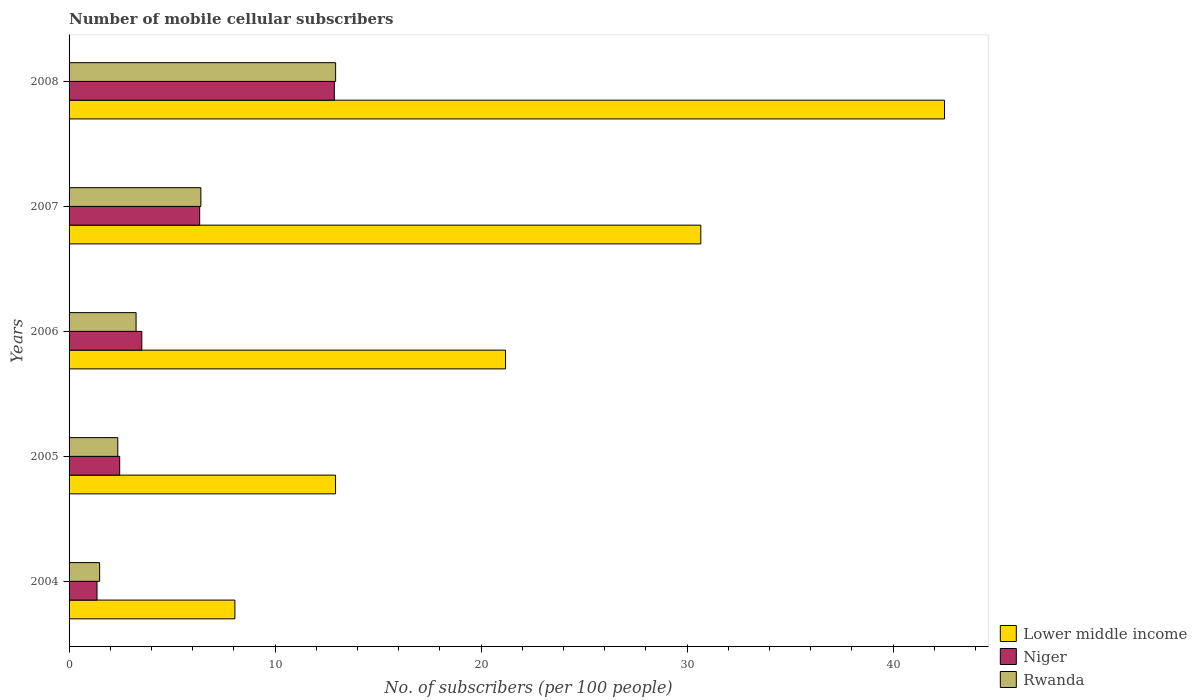How many groups of bars are there?
Offer a very short reply. 5. Are the number of bars on each tick of the Y-axis equal?
Your answer should be very brief. Yes. How many bars are there on the 3rd tick from the top?
Provide a short and direct response. 3. In how many cases, is the number of bars for a given year not equal to the number of legend labels?
Your answer should be compact. 0. What is the number of mobile cellular subscribers in Lower middle income in 2005?
Ensure brevity in your answer.  12.93. Across all years, what is the maximum number of mobile cellular subscribers in Rwanda?
Your response must be concise. 12.94. Across all years, what is the minimum number of mobile cellular subscribers in Rwanda?
Keep it short and to the point. 1.48. In which year was the number of mobile cellular subscribers in Rwanda maximum?
Your answer should be compact. 2008. In which year was the number of mobile cellular subscribers in Lower middle income minimum?
Provide a succinct answer. 2004. What is the total number of mobile cellular subscribers in Niger in the graph?
Keep it short and to the point. 26.56. What is the difference between the number of mobile cellular subscribers in Rwanda in 2005 and that in 2008?
Offer a very short reply. -10.57. What is the difference between the number of mobile cellular subscribers in Niger in 2004 and the number of mobile cellular subscribers in Rwanda in 2005?
Your response must be concise. -1.01. What is the average number of mobile cellular subscribers in Niger per year?
Provide a short and direct response. 5.31. In the year 2005, what is the difference between the number of mobile cellular subscribers in Rwanda and number of mobile cellular subscribers in Niger?
Make the answer very short. -0.09. What is the ratio of the number of mobile cellular subscribers in Lower middle income in 2004 to that in 2008?
Your answer should be compact. 0.19. Is the difference between the number of mobile cellular subscribers in Rwanda in 2005 and 2007 greater than the difference between the number of mobile cellular subscribers in Niger in 2005 and 2007?
Your answer should be compact. No. What is the difference between the highest and the second highest number of mobile cellular subscribers in Rwanda?
Offer a very short reply. 6.54. What is the difference between the highest and the lowest number of mobile cellular subscribers in Lower middle income?
Your answer should be very brief. 34.44. In how many years, is the number of mobile cellular subscribers in Rwanda greater than the average number of mobile cellular subscribers in Rwanda taken over all years?
Ensure brevity in your answer.  2. What does the 3rd bar from the top in 2008 represents?
Provide a short and direct response. Lower middle income. What does the 2nd bar from the bottom in 2008 represents?
Your answer should be compact. Niger. What is the difference between two consecutive major ticks on the X-axis?
Keep it short and to the point. 10. Are the values on the major ticks of X-axis written in scientific E-notation?
Your response must be concise. No. Does the graph contain any zero values?
Offer a terse response. No. Where does the legend appear in the graph?
Give a very brief answer. Bottom right. How many legend labels are there?
Give a very brief answer. 3. What is the title of the graph?
Make the answer very short. Number of mobile cellular subscribers. Does "Australia" appear as one of the legend labels in the graph?
Give a very brief answer. No. What is the label or title of the X-axis?
Ensure brevity in your answer.  No. of subscribers (per 100 people). What is the label or title of the Y-axis?
Give a very brief answer. Years. What is the No. of subscribers (per 100 people) in Lower middle income in 2004?
Provide a succinct answer. 8.05. What is the No. of subscribers (per 100 people) in Niger in 2004?
Ensure brevity in your answer.  1.36. What is the No. of subscribers (per 100 people) of Rwanda in 2004?
Make the answer very short. 1.48. What is the No. of subscribers (per 100 people) in Lower middle income in 2005?
Make the answer very short. 12.93. What is the No. of subscribers (per 100 people) of Niger in 2005?
Ensure brevity in your answer.  2.46. What is the No. of subscribers (per 100 people) in Rwanda in 2005?
Provide a succinct answer. 2.36. What is the No. of subscribers (per 100 people) of Lower middle income in 2006?
Provide a short and direct response. 21.19. What is the No. of subscribers (per 100 people) in Niger in 2006?
Offer a very short reply. 3.53. What is the No. of subscribers (per 100 people) in Rwanda in 2006?
Make the answer very short. 3.25. What is the No. of subscribers (per 100 people) in Lower middle income in 2007?
Offer a terse response. 30.66. What is the No. of subscribers (per 100 people) of Niger in 2007?
Offer a very short reply. 6.34. What is the No. of subscribers (per 100 people) of Rwanda in 2007?
Offer a terse response. 6.4. What is the No. of subscribers (per 100 people) in Lower middle income in 2008?
Give a very brief answer. 42.49. What is the No. of subscribers (per 100 people) of Niger in 2008?
Keep it short and to the point. 12.88. What is the No. of subscribers (per 100 people) of Rwanda in 2008?
Offer a very short reply. 12.94. Across all years, what is the maximum No. of subscribers (per 100 people) of Lower middle income?
Keep it short and to the point. 42.49. Across all years, what is the maximum No. of subscribers (per 100 people) in Niger?
Your response must be concise. 12.88. Across all years, what is the maximum No. of subscribers (per 100 people) of Rwanda?
Your response must be concise. 12.94. Across all years, what is the minimum No. of subscribers (per 100 people) in Lower middle income?
Your answer should be compact. 8.05. Across all years, what is the minimum No. of subscribers (per 100 people) of Niger?
Your answer should be very brief. 1.36. Across all years, what is the minimum No. of subscribers (per 100 people) in Rwanda?
Your answer should be compact. 1.48. What is the total No. of subscribers (per 100 people) of Lower middle income in the graph?
Provide a short and direct response. 115.32. What is the total No. of subscribers (per 100 people) of Niger in the graph?
Ensure brevity in your answer.  26.56. What is the total No. of subscribers (per 100 people) of Rwanda in the graph?
Offer a terse response. 26.44. What is the difference between the No. of subscribers (per 100 people) of Lower middle income in 2004 and that in 2005?
Provide a succinct answer. -4.89. What is the difference between the No. of subscribers (per 100 people) of Niger in 2004 and that in 2005?
Provide a short and direct response. -1.1. What is the difference between the No. of subscribers (per 100 people) in Rwanda in 2004 and that in 2005?
Provide a succinct answer. -0.88. What is the difference between the No. of subscribers (per 100 people) of Lower middle income in 2004 and that in 2006?
Give a very brief answer. -13.14. What is the difference between the No. of subscribers (per 100 people) of Niger in 2004 and that in 2006?
Offer a terse response. -2.17. What is the difference between the No. of subscribers (per 100 people) of Rwanda in 2004 and that in 2006?
Your answer should be very brief. -1.77. What is the difference between the No. of subscribers (per 100 people) in Lower middle income in 2004 and that in 2007?
Offer a very short reply. -22.61. What is the difference between the No. of subscribers (per 100 people) of Niger in 2004 and that in 2007?
Your answer should be compact. -4.98. What is the difference between the No. of subscribers (per 100 people) in Rwanda in 2004 and that in 2007?
Make the answer very short. -4.91. What is the difference between the No. of subscribers (per 100 people) in Lower middle income in 2004 and that in 2008?
Your response must be concise. -34.44. What is the difference between the No. of subscribers (per 100 people) in Niger in 2004 and that in 2008?
Give a very brief answer. -11.52. What is the difference between the No. of subscribers (per 100 people) in Rwanda in 2004 and that in 2008?
Your answer should be very brief. -11.45. What is the difference between the No. of subscribers (per 100 people) in Lower middle income in 2005 and that in 2006?
Ensure brevity in your answer.  -8.25. What is the difference between the No. of subscribers (per 100 people) of Niger in 2005 and that in 2006?
Your answer should be compact. -1.07. What is the difference between the No. of subscribers (per 100 people) of Rwanda in 2005 and that in 2006?
Give a very brief answer. -0.89. What is the difference between the No. of subscribers (per 100 people) in Lower middle income in 2005 and that in 2007?
Your answer should be very brief. -17.73. What is the difference between the No. of subscribers (per 100 people) of Niger in 2005 and that in 2007?
Keep it short and to the point. -3.88. What is the difference between the No. of subscribers (per 100 people) in Rwanda in 2005 and that in 2007?
Provide a succinct answer. -4.03. What is the difference between the No. of subscribers (per 100 people) in Lower middle income in 2005 and that in 2008?
Offer a very short reply. -29.56. What is the difference between the No. of subscribers (per 100 people) in Niger in 2005 and that in 2008?
Provide a succinct answer. -10.42. What is the difference between the No. of subscribers (per 100 people) of Rwanda in 2005 and that in 2008?
Provide a succinct answer. -10.57. What is the difference between the No. of subscribers (per 100 people) in Lower middle income in 2006 and that in 2007?
Your answer should be very brief. -9.48. What is the difference between the No. of subscribers (per 100 people) in Niger in 2006 and that in 2007?
Offer a terse response. -2.81. What is the difference between the No. of subscribers (per 100 people) in Rwanda in 2006 and that in 2007?
Offer a very short reply. -3.15. What is the difference between the No. of subscribers (per 100 people) of Lower middle income in 2006 and that in 2008?
Your answer should be compact. -21.31. What is the difference between the No. of subscribers (per 100 people) in Niger in 2006 and that in 2008?
Provide a short and direct response. -9.35. What is the difference between the No. of subscribers (per 100 people) in Rwanda in 2006 and that in 2008?
Provide a short and direct response. -9.69. What is the difference between the No. of subscribers (per 100 people) in Lower middle income in 2007 and that in 2008?
Your answer should be compact. -11.83. What is the difference between the No. of subscribers (per 100 people) in Niger in 2007 and that in 2008?
Provide a succinct answer. -6.54. What is the difference between the No. of subscribers (per 100 people) of Rwanda in 2007 and that in 2008?
Give a very brief answer. -6.54. What is the difference between the No. of subscribers (per 100 people) of Lower middle income in 2004 and the No. of subscribers (per 100 people) of Niger in 2005?
Your answer should be compact. 5.59. What is the difference between the No. of subscribers (per 100 people) in Lower middle income in 2004 and the No. of subscribers (per 100 people) in Rwanda in 2005?
Offer a terse response. 5.68. What is the difference between the No. of subscribers (per 100 people) in Niger in 2004 and the No. of subscribers (per 100 people) in Rwanda in 2005?
Give a very brief answer. -1.01. What is the difference between the No. of subscribers (per 100 people) in Lower middle income in 2004 and the No. of subscribers (per 100 people) in Niger in 2006?
Make the answer very short. 4.52. What is the difference between the No. of subscribers (per 100 people) of Lower middle income in 2004 and the No. of subscribers (per 100 people) of Rwanda in 2006?
Make the answer very short. 4.8. What is the difference between the No. of subscribers (per 100 people) in Niger in 2004 and the No. of subscribers (per 100 people) in Rwanda in 2006?
Your answer should be very brief. -1.9. What is the difference between the No. of subscribers (per 100 people) of Lower middle income in 2004 and the No. of subscribers (per 100 people) of Niger in 2007?
Provide a short and direct response. 1.71. What is the difference between the No. of subscribers (per 100 people) in Lower middle income in 2004 and the No. of subscribers (per 100 people) in Rwanda in 2007?
Offer a very short reply. 1.65. What is the difference between the No. of subscribers (per 100 people) in Niger in 2004 and the No. of subscribers (per 100 people) in Rwanda in 2007?
Ensure brevity in your answer.  -5.04. What is the difference between the No. of subscribers (per 100 people) of Lower middle income in 2004 and the No. of subscribers (per 100 people) of Niger in 2008?
Your answer should be very brief. -4.83. What is the difference between the No. of subscribers (per 100 people) in Lower middle income in 2004 and the No. of subscribers (per 100 people) in Rwanda in 2008?
Your answer should be compact. -4.89. What is the difference between the No. of subscribers (per 100 people) of Niger in 2004 and the No. of subscribers (per 100 people) of Rwanda in 2008?
Your answer should be very brief. -11.58. What is the difference between the No. of subscribers (per 100 people) of Lower middle income in 2005 and the No. of subscribers (per 100 people) of Niger in 2006?
Provide a short and direct response. 9.4. What is the difference between the No. of subscribers (per 100 people) in Lower middle income in 2005 and the No. of subscribers (per 100 people) in Rwanda in 2006?
Keep it short and to the point. 9.68. What is the difference between the No. of subscribers (per 100 people) of Niger in 2005 and the No. of subscribers (per 100 people) of Rwanda in 2006?
Provide a short and direct response. -0.8. What is the difference between the No. of subscribers (per 100 people) of Lower middle income in 2005 and the No. of subscribers (per 100 people) of Niger in 2007?
Ensure brevity in your answer.  6.59. What is the difference between the No. of subscribers (per 100 people) of Lower middle income in 2005 and the No. of subscribers (per 100 people) of Rwanda in 2007?
Keep it short and to the point. 6.54. What is the difference between the No. of subscribers (per 100 people) in Niger in 2005 and the No. of subscribers (per 100 people) in Rwanda in 2007?
Your response must be concise. -3.94. What is the difference between the No. of subscribers (per 100 people) in Lower middle income in 2005 and the No. of subscribers (per 100 people) in Niger in 2008?
Provide a short and direct response. 0.06. What is the difference between the No. of subscribers (per 100 people) of Lower middle income in 2005 and the No. of subscribers (per 100 people) of Rwanda in 2008?
Keep it short and to the point. -0. What is the difference between the No. of subscribers (per 100 people) of Niger in 2005 and the No. of subscribers (per 100 people) of Rwanda in 2008?
Ensure brevity in your answer.  -10.48. What is the difference between the No. of subscribers (per 100 people) in Lower middle income in 2006 and the No. of subscribers (per 100 people) in Niger in 2007?
Give a very brief answer. 14.85. What is the difference between the No. of subscribers (per 100 people) of Lower middle income in 2006 and the No. of subscribers (per 100 people) of Rwanda in 2007?
Keep it short and to the point. 14.79. What is the difference between the No. of subscribers (per 100 people) of Niger in 2006 and the No. of subscribers (per 100 people) of Rwanda in 2007?
Your answer should be compact. -2.87. What is the difference between the No. of subscribers (per 100 people) in Lower middle income in 2006 and the No. of subscribers (per 100 people) in Niger in 2008?
Provide a short and direct response. 8.31. What is the difference between the No. of subscribers (per 100 people) of Lower middle income in 2006 and the No. of subscribers (per 100 people) of Rwanda in 2008?
Your answer should be compact. 8.25. What is the difference between the No. of subscribers (per 100 people) in Niger in 2006 and the No. of subscribers (per 100 people) in Rwanda in 2008?
Your response must be concise. -9.41. What is the difference between the No. of subscribers (per 100 people) in Lower middle income in 2007 and the No. of subscribers (per 100 people) in Niger in 2008?
Your response must be concise. 17.79. What is the difference between the No. of subscribers (per 100 people) of Lower middle income in 2007 and the No. of subscribers (per 100 people) of Rwanda in 2008?
Your answer should be very brief. 17.73. What is the difference between the No. of subscribers (per 100 people) in Niger in 2007 and the No. of subscribers (per 100 people) in Rwanda in 2008?
Offer a very short reply. -6.6. What is the average No. of subscribers (per 100 people) in Lower middle income per year?
Ensure brevity in your answer.  23.06. What is the average No. of subscribers (per 100 people) of Niger per year?
Give a very brief answer. 5.31. What is the average No. of subscribers (per 100 people) of Rwanda per year?
Offer a terse response. 5.29. In the year 2004, what is the difference between the No. of subscribers (per 100 people) of Lower middle income and No. of subscribers (per 100 people) of Niger?
Keep it short and to the point. 6.69. In the year 2004, what is the difference between the No. of subscribers (per 100 people) in Lower middle income and No. of subscribers (per 100 people) in Rwanda?
Your answer should be very brief. 6.57. In the year 2004, what is the difference between the No. of subscribers (per 100 people) in Niger and No. of subscribers (per 100 people) in Rwanda?
Provide a succinct answer. -0.13. In the year 2005, what is the difference between the No. of subscribers (per 100 people) of Lower middle income and No. of subscribers (per 100 people) of Niger?
Ensure brevity in your answer.  10.48. In the year 2005, what is the difference between the No. of subscribers (per 100 people) of Lower middle income and No. of subscribers (per 100 people) of Rwanda?
Keep it short and to the point. 10.57. In the year 2005, what is the difference between the No. of subscribers (per 100 people) of Niger and No. of subscribers (per 100 people) of Rwanda?
Ensure brevity in your answer.  0.09. In the year 2006, what is the difference between the No. of subscribers (per 100 people) of Lower middle income and No. of subscribers (per 100 people) of Niger?
Your answer should be compact. 17.65. In the year 2006, what is the difference between the No. of subscribers (per 100 people) in Lower middle income and No. of subscribers (per 100 people) in Rwanda?
Your answer should be very brief. 17.93. In the year 2006, what is the difference between the No. of subscribers (per 100 people) in Niger and No. of subscribers (per 100 people) in Rwanda?
Make the answer very short. 0.28. In the year 2007, what is the difference between the No. of subscribers (per 100 people) in Lower middle income and No. of subscribers (per 100 people) in Niger?
Make the answer very short. 24.32. In the year 2007, what is the difference between the No. of subscribers (per 100 people) of Lower middle income and No. of subscribers (per 100 people) of Rwanda?
Ensure brevity in your answer.  24.27. In the year 2007, what is the difference between the No. of subscribers (per 100 people) in Niger and No. of subscribers (per 100 people) in Rwanda?
Your answer should be very brief. -0.06. In the year 2008, what is the difference between the No. of subscribers (per 100 people) of Lower middle income and No. of subscribers (per 100 people) of Niger?
Offer a terse response. 29.62. In the year 2008, what is the difference between the No. of subscribers (per 100 people) of Lower middle income and No. of subscribers (per 100 people) of Rwanda?
Offer a terse response. 29.55. In the year 2008, what is the difference between the No. of subscribers (per 100 people) in Niger and No. of subscribers (per 100 people) in Rwanda?
Offer a terse response. -0.06. What is the ratio of the No. of subscribers (per 100 people) in Lower middle income in 2004 to that in 2005?
Provide a short and direct response. 0.62. What is the ratio of the No. of subscribers (per 100 people) of Niger in 2004 to that in 2005?
Provide a succinct answer. 0.55. What is the ratio of the No. of subscribers (per 100 people) of Rwanda in 2004 to that in 2005?
Your answer should be compact. 0.63. What is the ratio of the No. of subscribers (per 100 people) in Lower middle income in 2004 to that in 2006?
Make the answer very short. 0.38. What is the ratio of the No. of subscribers (per 100 people) of Niger in 2004 to that in 2006?
Your response must be concise. 0.38. What is the ratio of the No. of subscribers (per 100 people) of Rwanda in 2004 to that in 2006?
Provide a succinct answer. 0.46. What is the ratio of the No. of subscribers (per 100 people) of Lower middle income in 2004 to that in 2007?
Provide a succinct answer. 0.26. What is the ratio of the No. of subscribers (per 100 people) of Niger in 2004 to that in 2007?
Your answer should be very brief. 0.21. What is the ratio of the No. of subscribers (per 100 people) of Rwanda in 2004 to that in 2007?
Make the answer very short. 0.23. What is the ratio of the No. of subscribers (per 100 people) of Lower middle income in 2004 to that in 2008?
Make the answer very short. 0.19. What is the ratio of the No. of subscribers (per 100 people) of Niger in 2004 to that in 2008?
Your answer should be compact. 0.11. What is the ratio of the No. of subscribers (per 100 people) in Rwanda in 2004 to that in 2008?
Your response must be concise. 0.11. What is the ratio of the No. of subscribers (per 100 people) in Lower middle income in 2005 to that in 2006?
Your response must be concise. 0.61. What is the ratio of the No. of subscribers (per 100 people) of Niger in 2005 to that in 2006?
Make the answer very short. 0.7. What is the ratio of the No. of subscribers (per 100 people) in Rwanda in 2005 to that in 2006?
Make the answer very short. 0.73. What is the ratio of the No. of subscribers (per 100 people) of Lower middle income in 2005 to that in 2007?
Your answer should be very brief. 0.42. What is the ratio of the No. of subscribers (per 100 people) in Niger in 2005 to that in 2007?
Give a very brief answer. 0.39. What is the ratio of the No. of subscribers (per 100 people) in Rwanda in 2005 to that in 2007?
Provide a succinct answer. 0.37. What is the ratio of the No. of subscribers (per 100 people) in Lower middle income in 2005 to that in 2008?
Make the answer very short. 0.3. What is the ratio of the No. of subscribers (per 100 people) in Niger in 2005 to that in 2008?
Your answer should be very brief. 0.19. What is the ratio of the No. of subscribers (per 100 people) in Rwanda in 2005 to that in 2008?
Give a very brief answer. 0.18. What is the ratio of the No. of subscribers (per 100 people) of Lower middle income in 2006 to that in 2007?
Your answer should be compact. 0.69. What is the ratio of the No. of subscribers (per 100 people) of Niger in 2006 to that in 2007?
Ensure brevity in your answer.  0.56. What is the ratio of the No. of subscribers (per 100 people) in Rwanda in 2006 to that in 2007?
Your response must be concise. 0.51. What is the ratio of the No. of subscribers (per 100 people) of Lower middle income in 2006 to that in 2008?
Provide a succinct answer. 0.5. What is the ratio of the No. of subscribers (per 100 people) in Niger in 2006 to that in 2008?
Offer a terse response. 0.27. What is the ratio of the No. of subscribers (per 100 people) in Rwanda in 2006 to that in 2008?
Make the answer very short. 0.25. What is the ratio of the No. of subscribers (per 100 people) in Lower middle income in 2007 to that in 2008?
Offer a terse response. 0.72. What is the ratio of the No. of subscribers (per 100 people) in Niger in 2007 to that in 2008?
Make the answer very short. 0.49. What is the ratio of the No. of subscribers (per 100 people) in Rwanda in 2007 to that in 2008?
Ensure brevity in your answer.  0.49. What is the difference between the highest and the second highest No. of subscribers (per 100 people) of Lower middle income?
Offer a very short reply. 11.83. What is the difference between the highest and the second highest No. of subscribers (per 100 people) of Niger?
Give a very brief answer. 6.54. What is the difference between the highest and the second highest No. of subscribers (per 100 people) of Rwanda?
Provide a succinct answer. 6.54. What is the difference between the highest and the lowest No. of subscribers (per 100 people) in Lower middle income?
Make the answer very short. 34.44. What is the difference between the highest and the lowest No. of subscribers (per 100 people) of Niger?
Make the answer very short. 11.52. What is the difference between the highest and the lowest No. of subscribers (per 100 people) in Rwanda?
Make the answer very short. 11.45. 